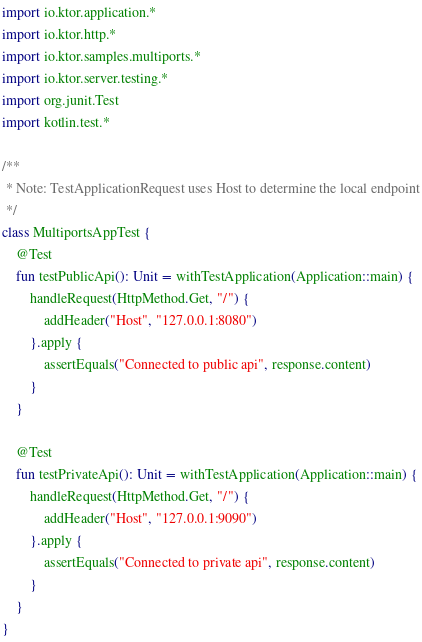<code> <loc_0><loc_0><loc_500><loc_500><_Kotlin_>import io.ktor.application.*
import io.ktor.http.*
import io.ktor.samples.multiports.*
import io.ktor.server.testing.*
import org.junit.Test
import kotlin.test.*

/**
 * Note: TestApplicationRequest uses Host to determine the local endpoint
 */
class MultiportsAppTest {
    @Test
    fun testPublicApi(): Unit = withTestApplication(Application::main) {
        handleRequest(HttpMethod.Get, "/") {
            addHeader("Host", "127.0.0.1:8080")
        }.apply {
            assertEquals("Connected to public api", response.content)
        }
    }

    @Test
    fun testPrivateApi(): Unit = withTestApplication(Application::main) {
        handleRequest(HttpMethod.Get, "/") {
            addHeader("Host", "127.0.0.1:9090")
        }.apply {
            assertEquals("Connected to private api", response.content)
        }
    }
}
</code> 